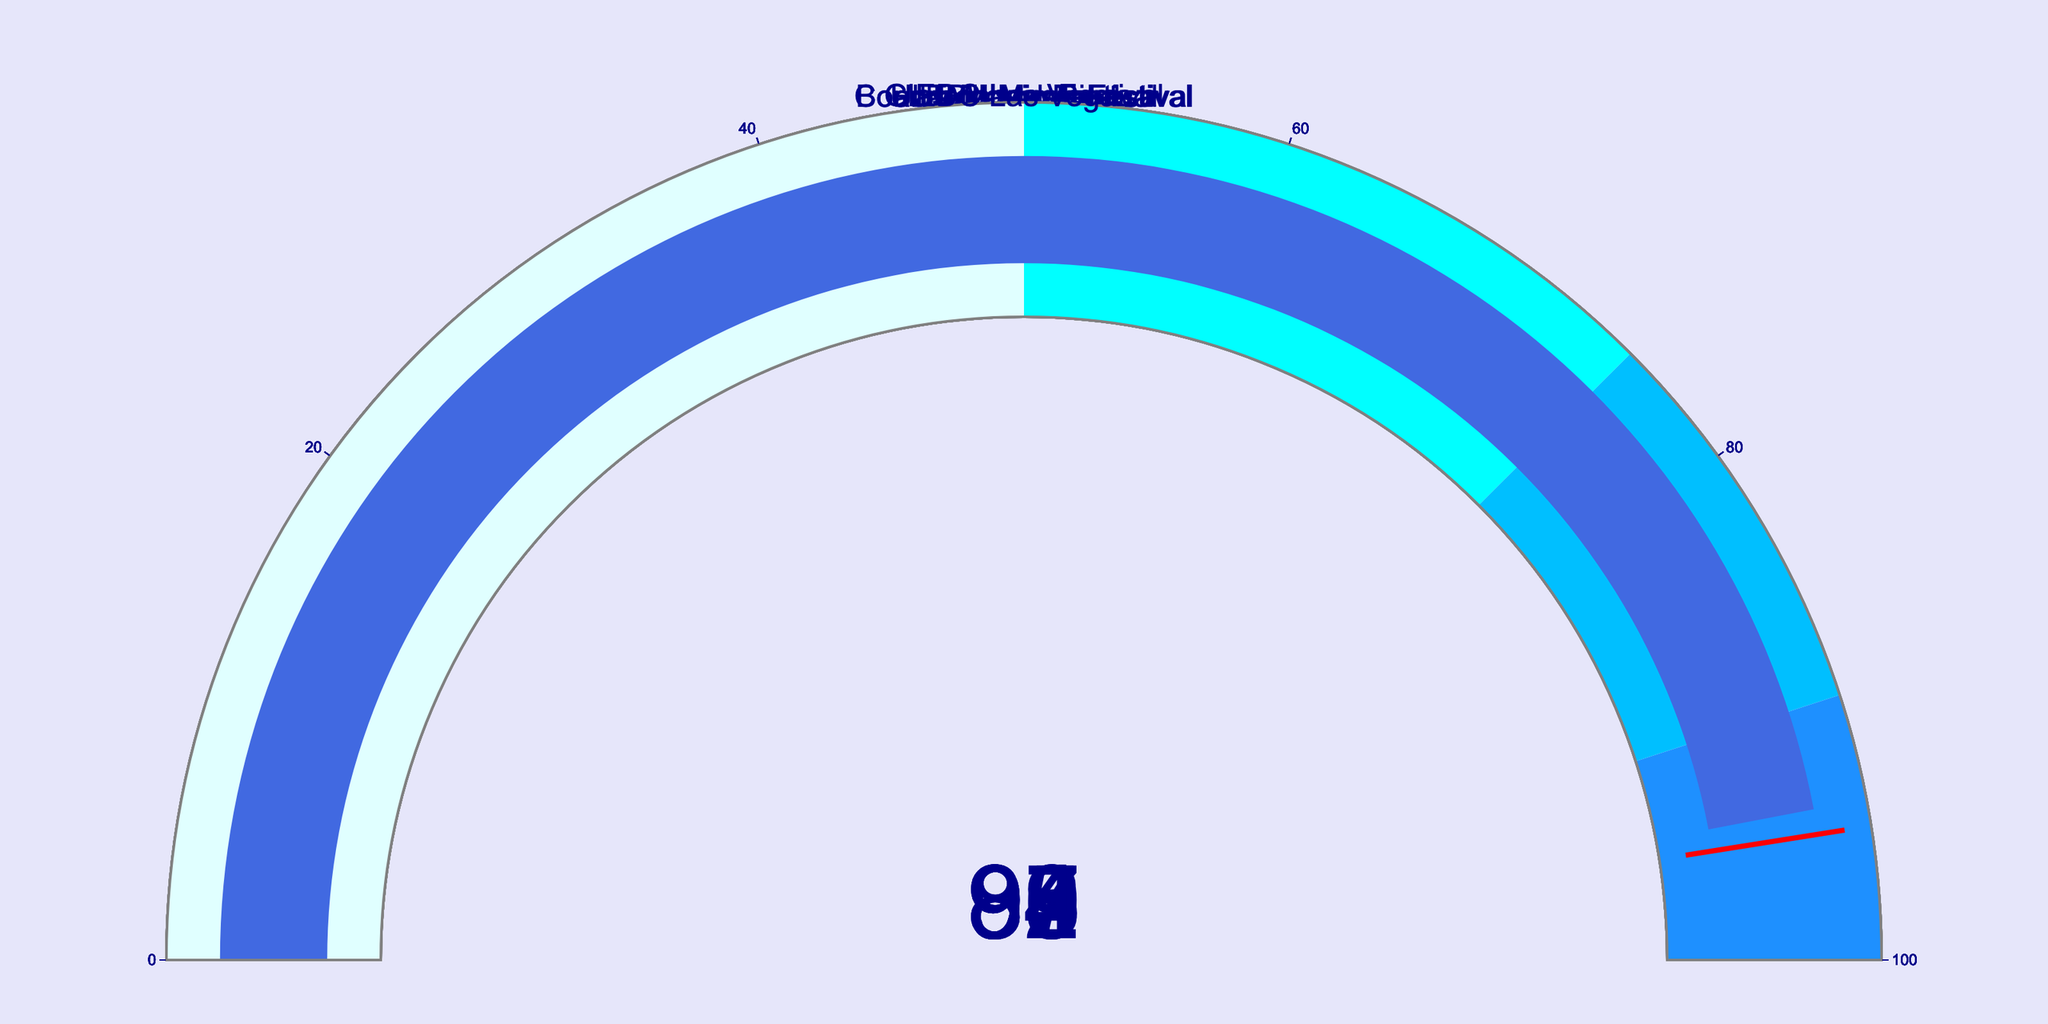What's the rating for Coachella Music Festival? To determine the rating, locate the gauge chart labeled "Coachella Music Festival" and read the number displayed on the gauge.
Answer: 92 How many events have a rating above 90? Count the number of gauge charts where the displayed rating is greater than 90.
Answer: 5 What's the difference in ratings between Tomorrowland and Rock in Rio? Locate the gauge charts for "Tomorrowland" and "Rock in Rio". Subtract the rating of Rock in Rio (87) from Tomorrowland's (95).
Answer: 8 Which event has the lowest rating? Compare all gauge charts and identify the one with the lowest numerical value among all displayed ratings.
Answer: Rock in Rio What is the average rating across all events? Add all the ratings (92 + 88 + 95 + 87 + 90 + 93 + 89 + 94), then divide by the number of events (8).
Answer: 91 Between Lollapalooza and Ultra Music Festival, which has a higher rating? Locate the gauge charts for "Lollapalooza" and "Ultra Music Festival". Compare the two numerical ratings to determine the higher value.
Answer: Ultra Music Festival How many events have a rating in the range of 75 to 90 inclusive? Count the number of gauge charts where the displayed rating falls between 75 and 90, inclusive.
Answer: 4 What's the combined rating of Glastonbury Festival and EDC Las Vegas? Add the ratings of Glastonbury Festival (88) and EDC Las Vegas (94).
Answer: 182 